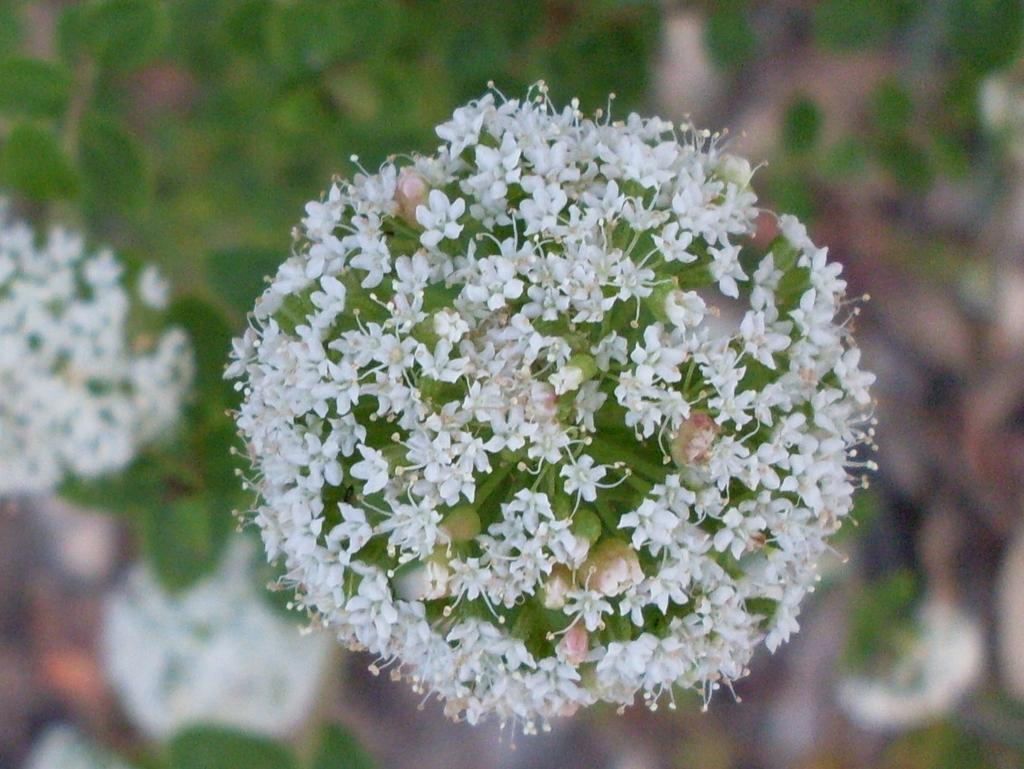What type of plant is featured in the image? There is a plant with flowers in the image. Can you describe the background of the image? The background of the image is slightly blurred. What else can be seen in the background of the image? Plants and flowers are visible in the background of the image. What type of polish is being applied to the flowers in the image? There is no polish being applied to the flowers in the image; it is a photograph of a plant with flowers. What song is being sung by the flowers in the image? There is no song being sung by the flowers in the image; they are not capable of singing. 